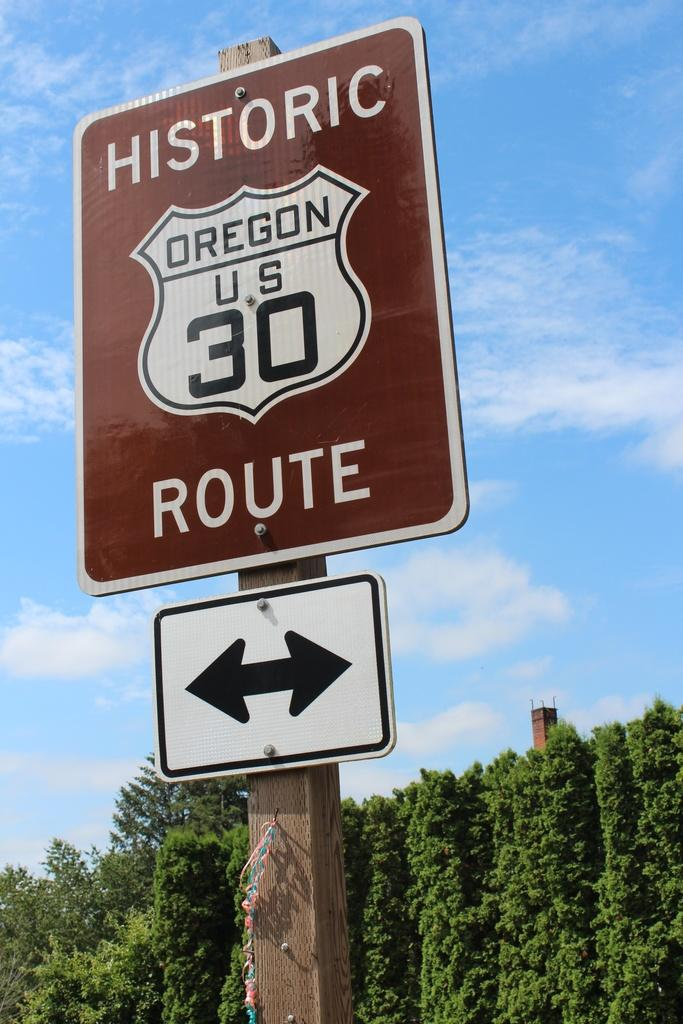What is the main object in the image? There is a pole in the image. What is attached to the pole? There is a board on the pole. What can be read on the board? There is text on the board. What can be seen in the background of the image? There are trees and the sky visible in the background of the image. How many jelly containers can be seen on the pole in the image? There are no jelly containers present in the image. What type of dinosaur is depicted on the board in the image? There are no dinosaurs depicted on the board in the image. 